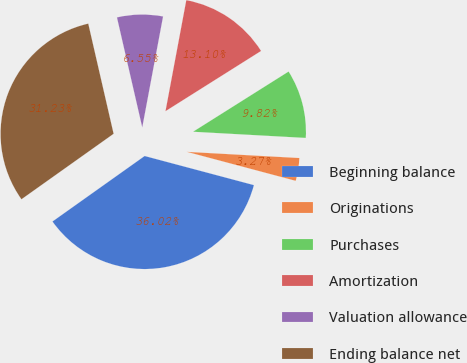Convert chart. <chart><loc_0><loc_0><loc_500><loc_500><pie_chart><fcel>Beginning balance<fcel>Originations<fcel>Purchases<fcel>Amortization<fcel>Valuation allowance<fcel>Ending balance net<nl><fcel>36.02%<fcel>3.27%<fcel>9.82%<fcel>13.1%<fcel>6.55%<fcel>31.23%<nl></chart> 